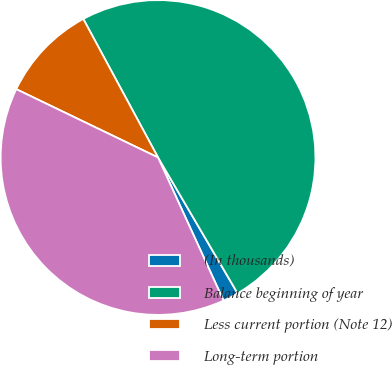Convert chart to OTSL. <chart><loc_0><loc_0><loc_500><loc_500><pie_chart><fcel>(In thousands)<fcel>Balance beginning of year<fcel>Less current portion (Note 12)<fcel>Long-term portion<nl><fcel>1.6%<fcel>49.45%<fcel>9.98%<fcel>38.98%<nl></chart> 